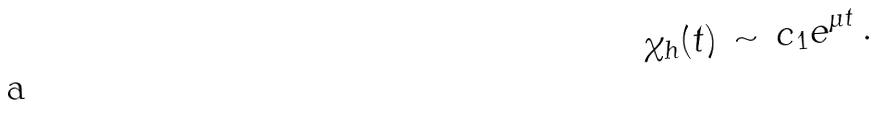Convert formula to latex. <formula><loc_0><loc_0><loc_500><loc_500>\chi _ { h } ( t ) \, \sim \, c _ { 1 } e ^ { \mu t } \, .</formula> 